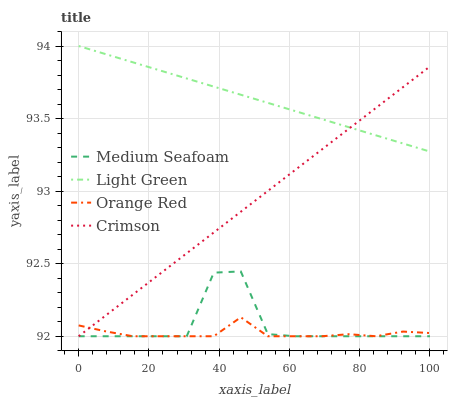Does Orange Red have the minimum area under the curve?
Answer yes or no. Yes. Does Light Green have the maximum area under the curve?
Answer yes or no. Yes. Does Medium Seafoam have the minimum area under the curve?
Answer yes or no. No. Does Medium Seafoam have the maximum area under the curve?
Answer yes or no. No. Is Crimson the smoothest?
Answer yes or no. Yes. Is Medium Seafoam the roughest?
Answer yes or no. Yes. Is Light Green the smoothest?
Answer yes or no. No. Is Light Green the roughest?
Answer yes or no. No. Does Crimson have the lowest value?
Answer yes or no. Yes. Does Light Green have the lowest value?
Answer yes or no. No. Does Light Green have the highest value?
Answer yes or no. Yes. Does Medium Seafoam have the highest value?
Answer yes or no. No. Is Medium Seafoam less than Light Green?
Answer yes or no. Yes. Is Light Green greater than Medium Seafoam?
Answer yes or no. Yes. Does Medium Seafoam intersect Orange Red?
Answer yes or no. Yes. Is Medium Seafoam less than Orange Red?
Answer yes or no. No. Is Medium Seafoam greater than Orange Red?
Answer yes or no. No. Does Medium Seafoam intersect Light Green?
Answer yes or no. No. 